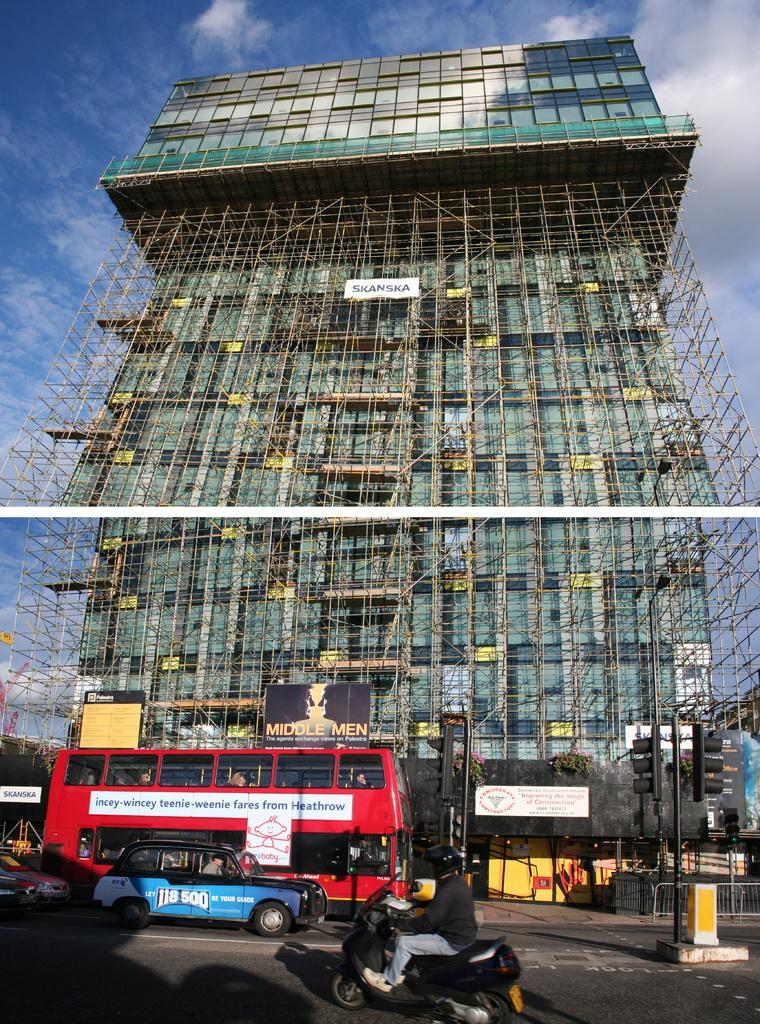What type of vehicles can be seen in the image? There are buses in the image. What is the man in the image doing? The man is sitting on a motorcycle in the image. What is the purpose of the fence in the image? The purpose of the fence in the image is not clear, but it could be to mark a boundary or provide security. What is written on the banner in the image? The content of the banner is not mentioned in the facts, so we cannot determine what is written on it. What type of structure is visible in the image? There is a building in the image. What is visible in the sky in the image? The sky is visible in the image, and there are clouds present. How does the man in the image help with scientific research? There is no information provided about the man's involvement in scientific research, so we cannot determine how he helps with it. 